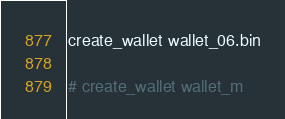Convert code to text. <code><loc_0><loc_0><loc_500><loc_500><_Bash_>create_wallet wallet_06.bin

# create_wallet wallet_m


</code> 